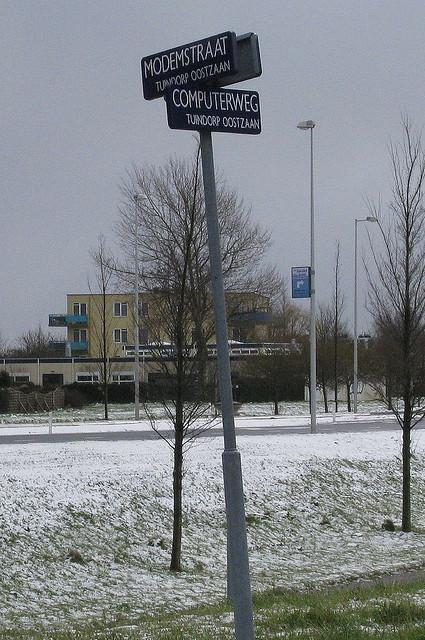How many trees are on this field?
Give a very brief answer. 2. 